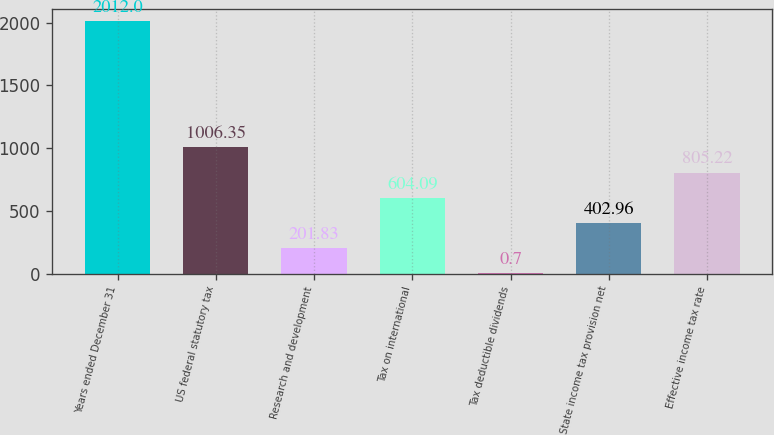Convert chart. <chart><loc_0><loc_0><loc_500><loc_500><bar_chart><fcel>Years ended December 31<fcel>US federal statutory tax<fcel>Research and development<fcel>Tax on international<fcel>Tax deductible dividends<fcel>State income tax provision net<fcel>Effective income tax rate<nl><fcel>2012<fcel>1006.35<fcel>201.83<fcel>604.09<fcel>0.7<fcel>402.96<fcel>805.22<nl></chart> 